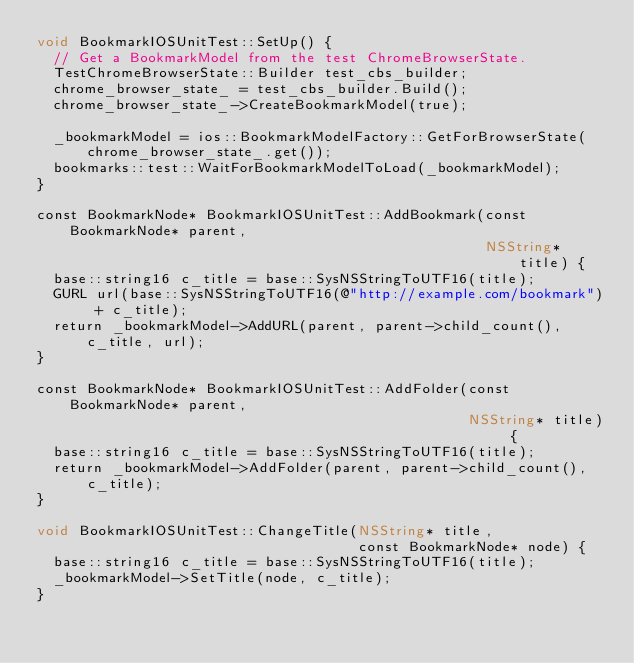<code> <loc_0><loc_0><loc_500><loc_500><_ObjectiveC_>void BookmarkIOSUnitTest::SetUp() {
  // Get a BookmarkModel from the test ChromeBrowserState.
  TestChromeBrowserState::Builder test_cbs_builder;
  chrome_browser_state_ = test_cbs_builder.Build();
  chrome_browser_state_->CreateBookmarkModel(true);

  _bookmarkModel = ios::BookmarkModelFactory::GetForBrowserState(
      chrome_browser_state_.get());
  bookmarks::test::WaitForBookmarkModelToLoad(_bookmarkModel);
}

const BookmarkNode* BookmarkIOSUnitTest::AddBookmark(const BookmarkNode* parent,
                                                     NSString* title) {
  base::string16 c_title = base::SysNSStringToUTF16(title);
  GURL url(base::SysNSStringToUTF16(@"http://example.com/bookmark") + c_title);
  return _bookmarkModel->AddURL(parent, parent->child_count(), c_title, url);
}

const BookmarkNode* BookmarkIOSUnitTest::AddFolder(const BookmarkNode* parent,
                                                   NSString* title) {
  base::string16 c_title = base::SysNSStringToUTF16(title);
  return _bookmarkModel->AddFolder(parent, parent->child_count(), c_title);
}

void BookmarkIOSUnitTest::ChangeTitle(NSString* title,
                                      const BookmarkNode* node) {
  base::string16 c_title = base::SysNSStringToUTF16(title);
  _bookmarkModel->SetTitle(node, c_title);
}
</code> 